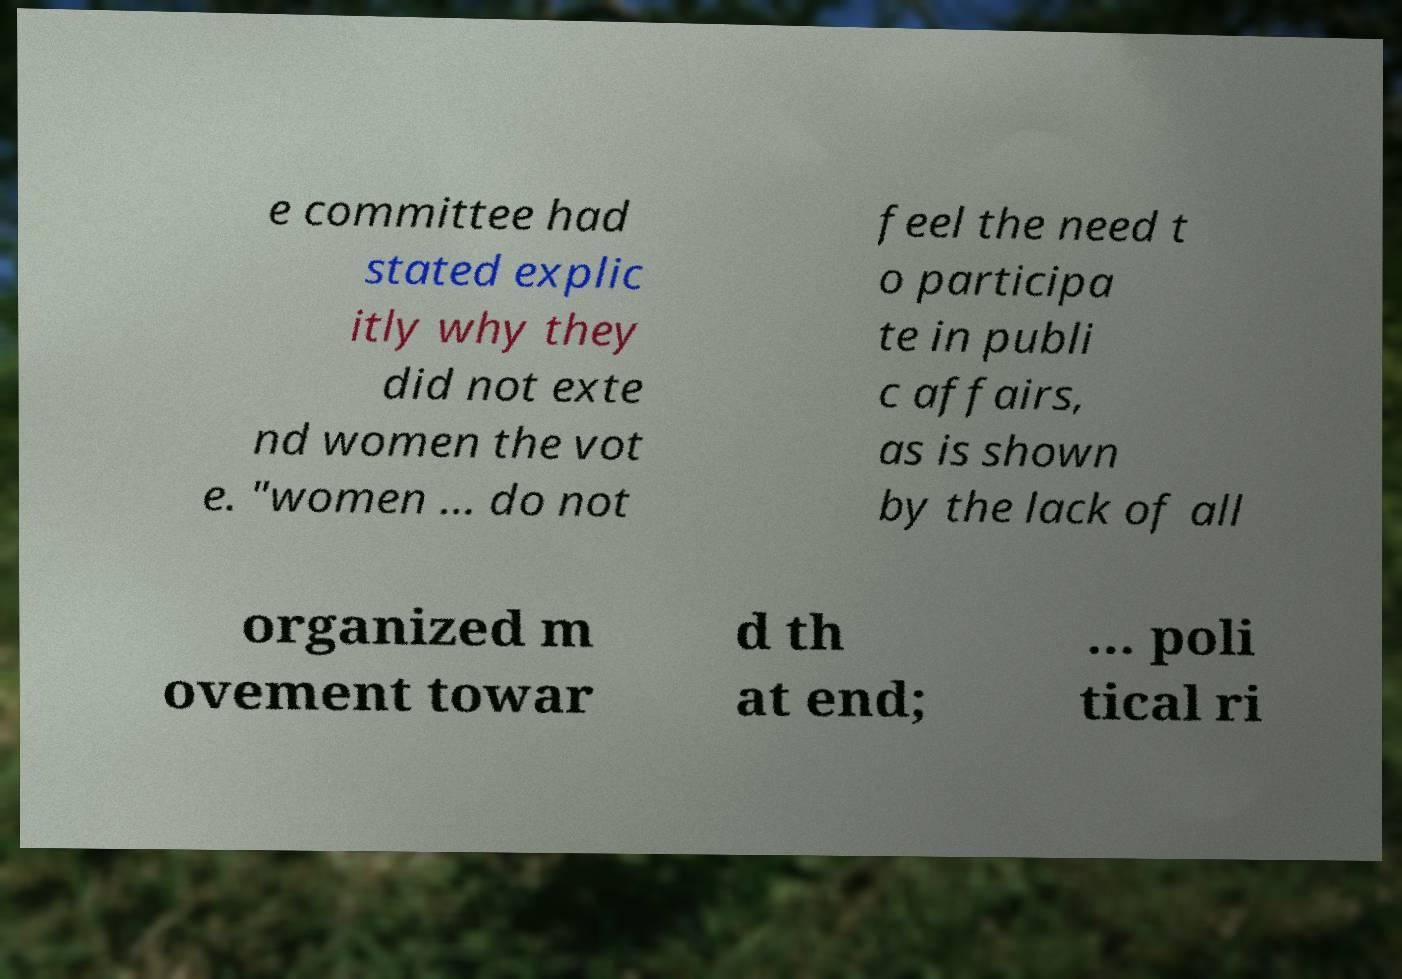For documentation purposes, I need the text within this image transcribed. Could you provide that? e committee had stated explic itly why they did not exte nd women the vot e. "women … do not feel the need t o participa te in publi c affairs, as is shown by the lack of all organized m ovement towar d th at end; … poli tical ri 